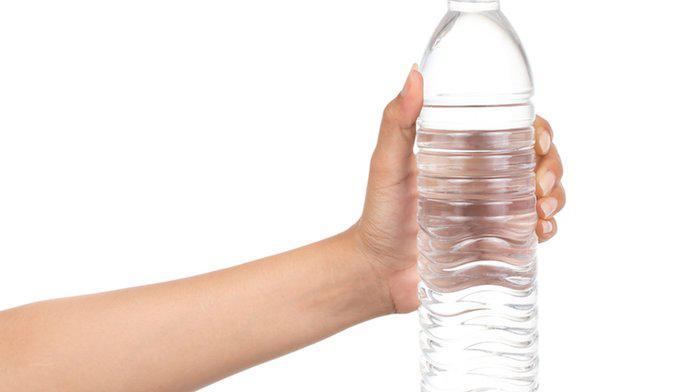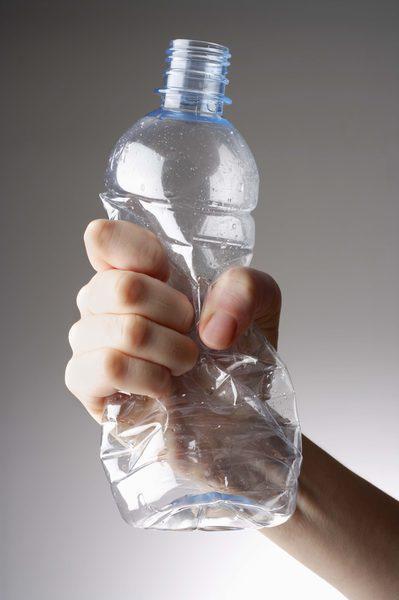The first image is the image on the left, the second image is the image on the right. Given the left and right images, does the statement "The left and right image contains the same number of water bottles and hands." hold true? Answer yes or no. Yes. The first image is the image on the left, the second image is the image on the right. Examine the images to the left and right. Is the description "Each image shows exactly one hand holding one water bottle." accurate? Answer yes or no. Yes. 